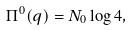Convert formula to latex. <formula><loc_0><loc_0><loc_500><loc_500>\Pi ^ { 0 } ( q ) = N _ { 0 } \log 4 ,</formula> 